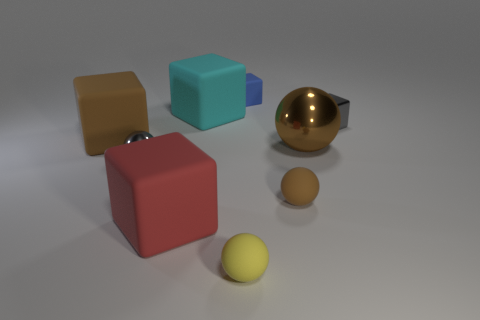There is a small rubber object that is behind the big brown rubber object; what color is it?
Give a very brief answer. Blue. Is the metallic cube the same size as the brown rubber sphere?
Make the answer very short. Yes. There is a brown object that is left of the large rubber block that is in front of the tiny gray metal ball; what is its material?
Your answer should be very brief. Rubber. What number of shiny spheres are the same color as the tiny shiny block?
Your answer should be compact. 1. Is there any other thing that has the same material as the large brown sphere?
Offer a terse response. Yes. Is the number of large things behind the tiny brown thing less than the number of tiny yellow matte spheres?
Provide a short and direct response. No. There is a large rubber object that is left of the tiny metal thing that is on the left side of the large metallic sphere; what color is it?
Your response must be concise. Brown. There is a gray metallic object left of the small gray object that is to the right of the large block that is behind the big brown block; what size is it?
Offer a very short reply. Small. Are there fewer tiny gray metallic spheres that are behind the blue matte object than large cyan objects that are behind the red block?
Provide a short and direct response. Yes. How many big purple cylinders have the same material as the blue cube?
Provide a short and direct response. 0. 